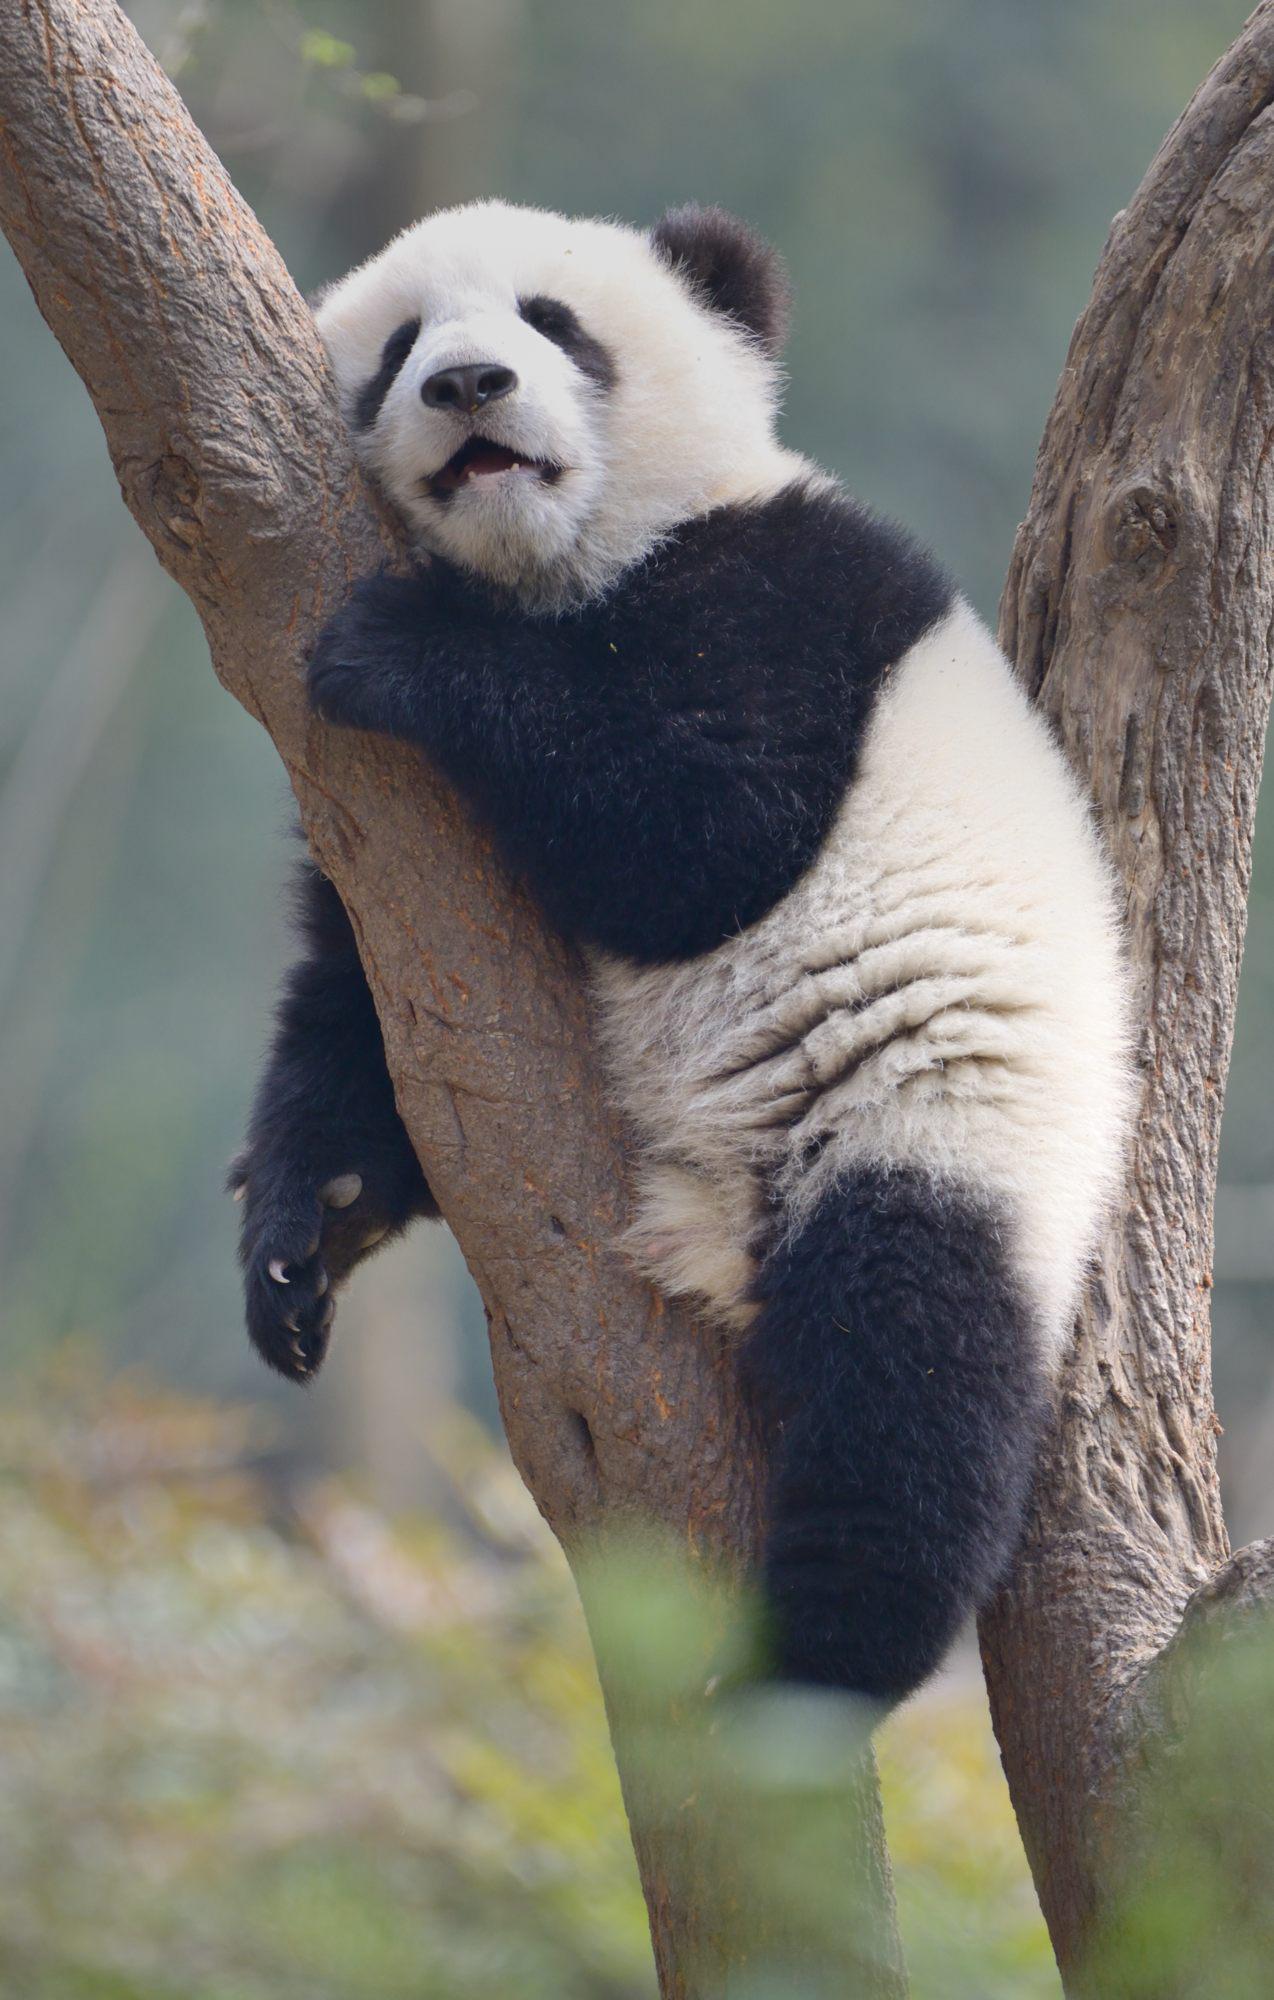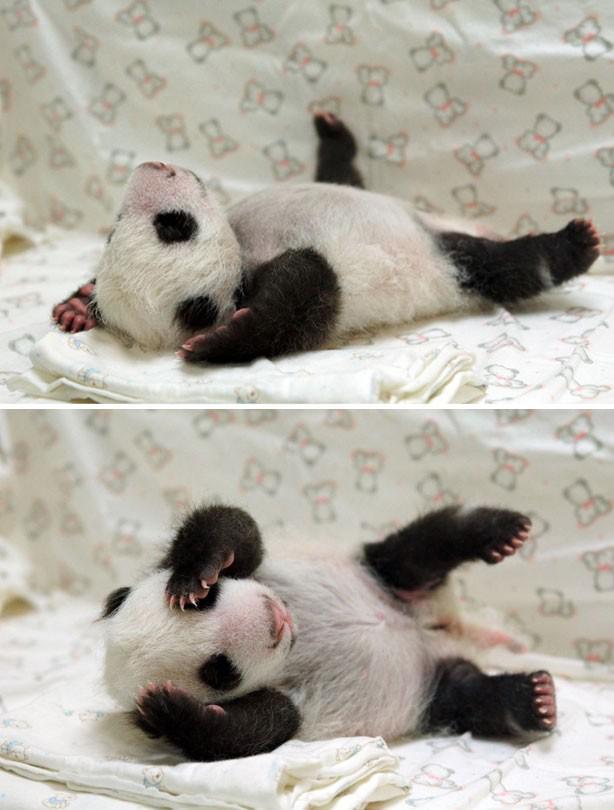The first image is the image on the left, the second image is the image on the right. For the images displayed, is the sentence "There are three pandas in total." factually correct? Answer yes or no. Yes. The first image is the image on the left, the second image is the image on the right. Assess this claim about the two images: "Images show a total of two panda bears relaxing in the branches of leafless trees.". Correct or not? Answer yes or no. No. 